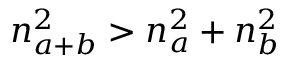<formula> <loc_0><loc_0><loc_500><loc_500>n _ { a + b } ^ { 2 } > n _ { a } ^ { 2 } + n _ { b } ^ { 2 }</formula> 